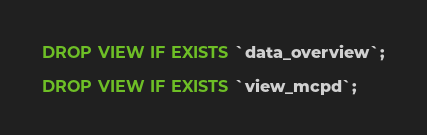<code> <loc_0><loc_0><loc_500><loc_500><_SQL_>DROP VIEW IF EXISTS `data_overview`;

DROP VIEW IF EXISTS `view_mcpd`;</code> 